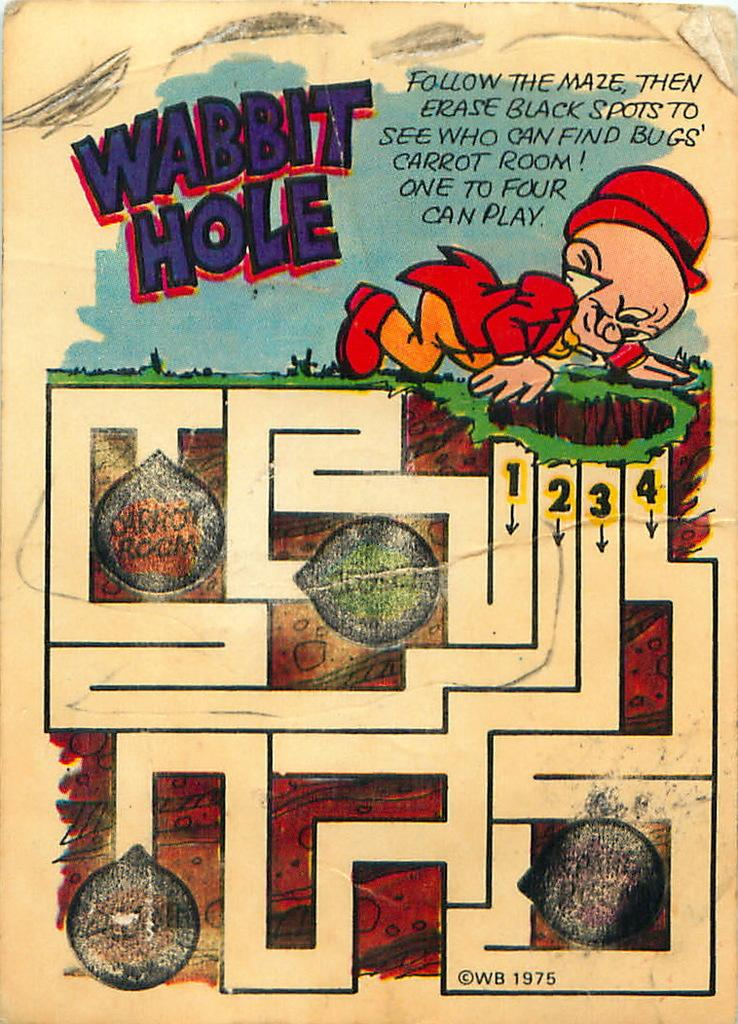<image>
Describe the image concisely. A looney tunes themed maze called Wabbit Hole 